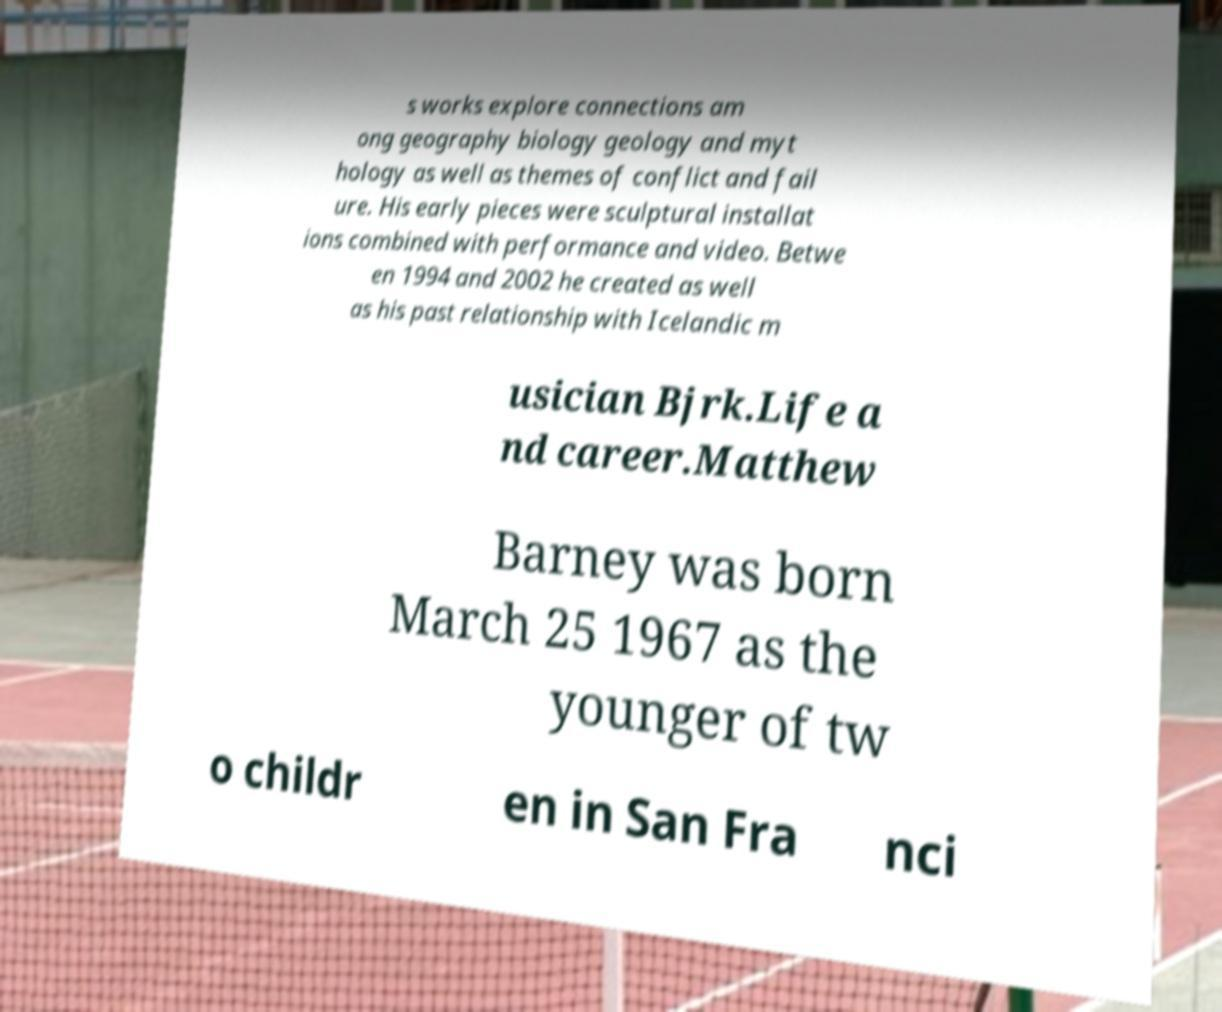There's text embedded in this image that I need extracted. Can you transcribe it verbatim? s works explore connections am ong geography biology geology and myt hology as well as themes of conflict and fail ure. His early pieces were sculptural installat ions combined with performance and video. Betwe en 1994 and 2002 he created as well as his past relationship with Icelandic m usician Bjrk.Life a nd career.Matthew Barney was born March 25 1967 as the younger of tw o childr en in San Fra nci 